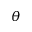<formula> <loc_0><loc_0><loc_500><loc_500>\theta</formula> 